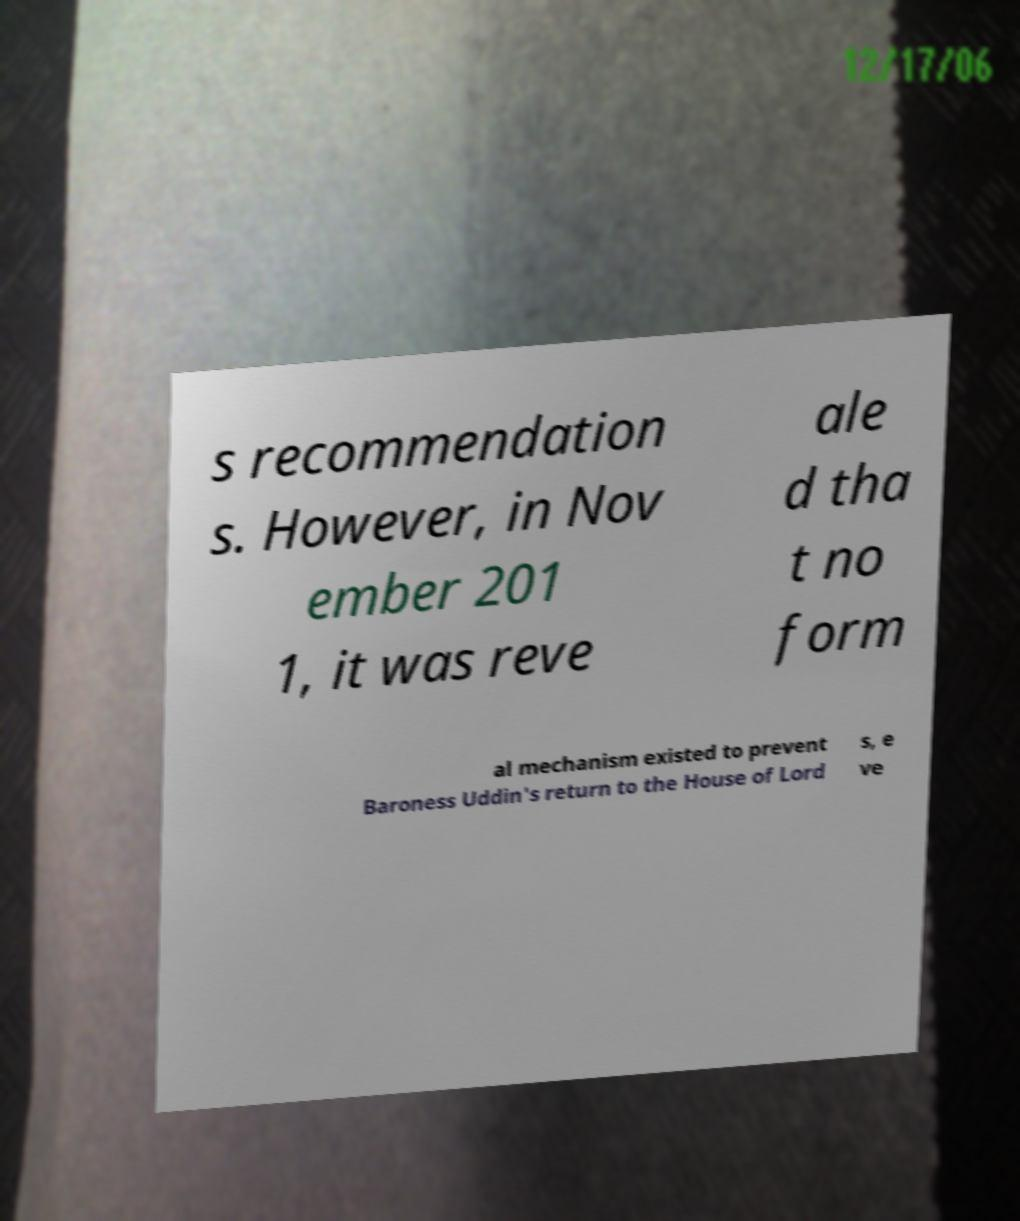Please read and relay the text visible in this image. What does it say? s recommendation s. However, in Nov ember 201 1, it was reve ale d tha t no form al mechanism existed to prevent Baroness Uddin's return to the House of Lord s, e ve 